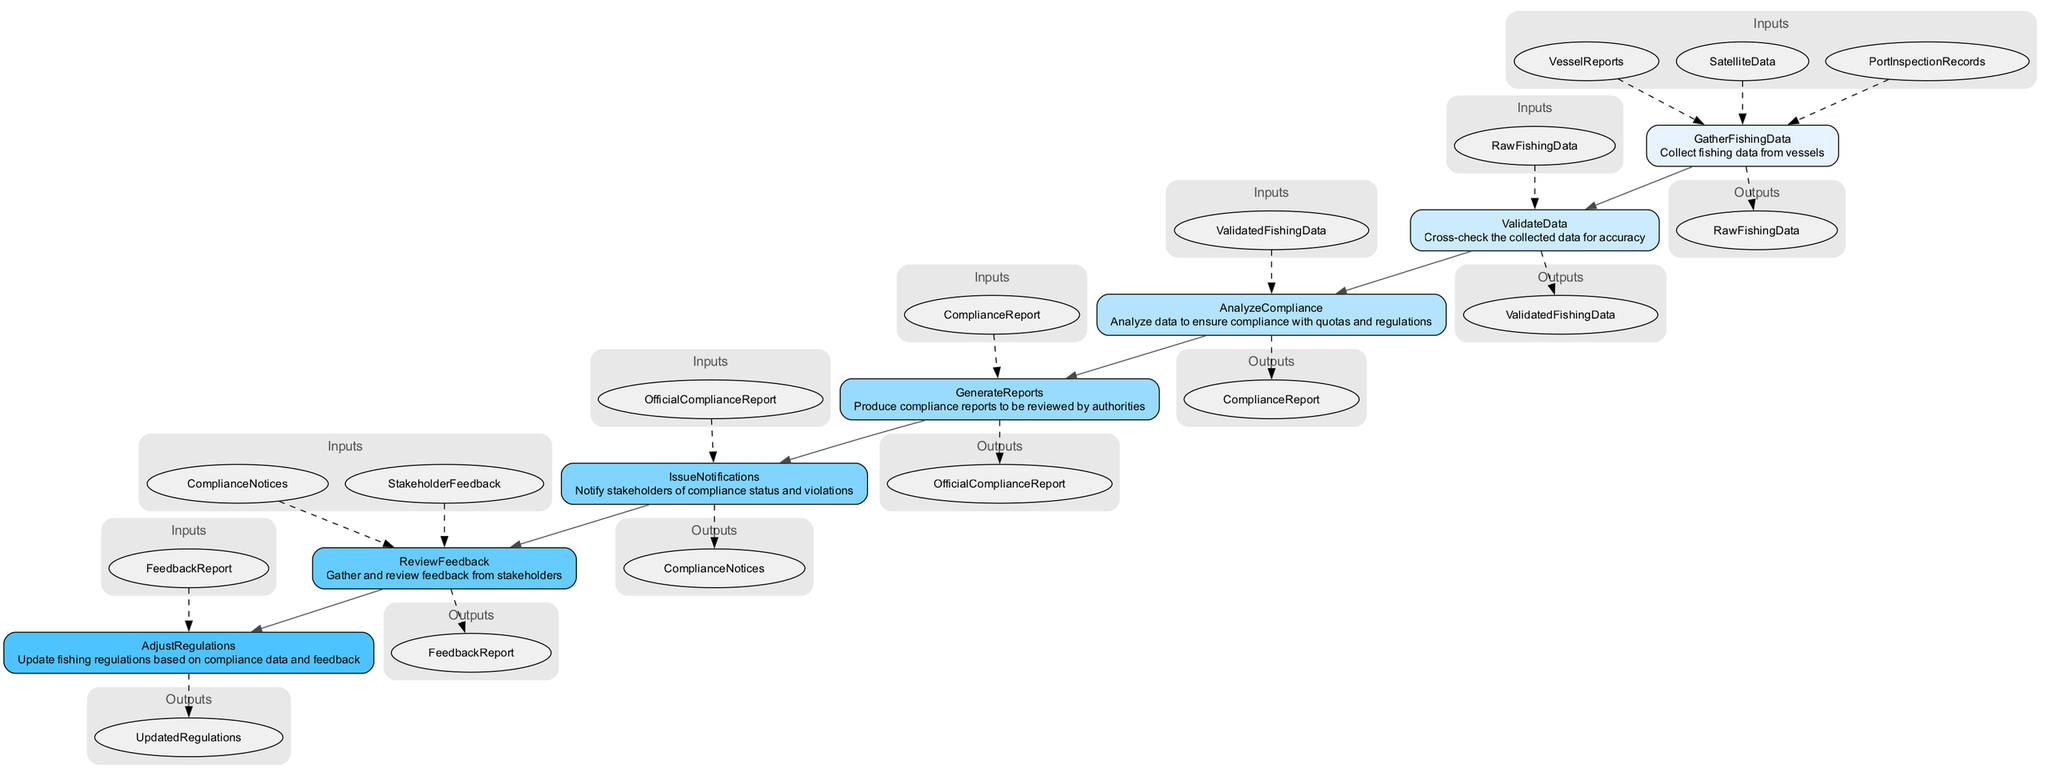What is the first step in the Compliance Monitoring and Reporting System? The first step in the flowchart is labeled "GatherFishingData." It is identified as the starting point that initiates the process by collecting fishing data from vessels.
Answer: GatherFishingData How many outputs does the ValidateData step produce? The ValidateData step produces one output, which is "ValidatedFishingData." This is determined by looking at the outputs listed under this specific step in the diagram.
Answer: One What are the recipients of the OfficialComplianceReport? The recipients identified for the OfficialComplianceReport are "GovernmentAuthorities" and "InternationalRegulatoryBodies." This information is visible under the GenerateReports step, where it specifies to whom the report is delivered.
Answer: GovernmentAuthorities, InternationalRegulatoryBodies What is the purpose of the AnalyzeCompliance step? The AnalyzeCompliance step is aimed at analyzing data to ensure compliance with quotas and regulations, as indicated in its description. This purpose drives the functions that follow in the system's flow.
Answer: Analyze data to ensure compliance Which step follows the ValidateData step? The step that follows ValidateData is AnalyzeCompliance. This can be understood by reviewing the directional edges in the diagram that indicate the flow from one step to the next in the process.
Answer: AnalyzeCompliance What is the final output of the Compliance Monitoring and Reporting System? The final output produced as a result of the Compliance Monitoring and Reporting System is "UpdatedRegulations." This output is the last in the flow, coming after the entire compliance process has been reviewed and adjusted.
Answer: UpdatedRegulations How many total steps are there in the Compliance Monitoring and Reporting System? There are seven total steps listed in the diagram, spanning from GatherFishingData to AdjustRegulations. Each step is counted sequentially in the flowchart.
Answer: Seven What action does the ReviewFeedback step perform? The ReviewFeedback step gathers and reviews feedback from stakeholders. This action is summarized in the step's description, explaining the purpose of this particular node in the diagram.
Answer: Gather and review feedback 